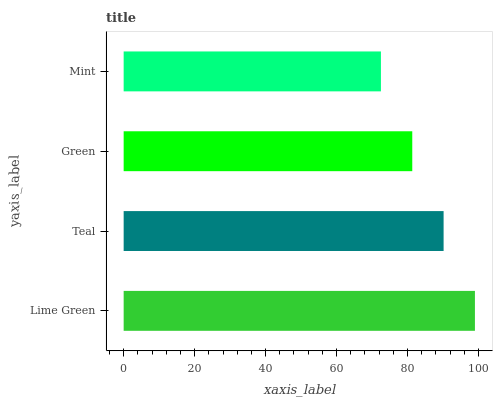Is Mint the minimum?
Answer yes or no. Yes. Is Lime Green the maximum?
Answer yes or no. Yes. Is Teal the minimum?
Answer yes or no. No. Is Teal the maximum?
Answer yes or no. No. Is Lime Green greater than Teal?
Answer yes or no. Yes. Is Teal less than Lime Green?
Answer yes or no. Yes. Is Teal greater than Lime Green?
Answer yes or no. No. Is Lime Green less than Teal?
Answer yes or no. No. Is Teal the high median?
Answer yes or no. Yes. Is Green the low median?
Answer yes or no. Yes. Is Lime Green the high median?
Answer yes or no. No. Is Lime Green the low median?
Answer yes or no. No. 